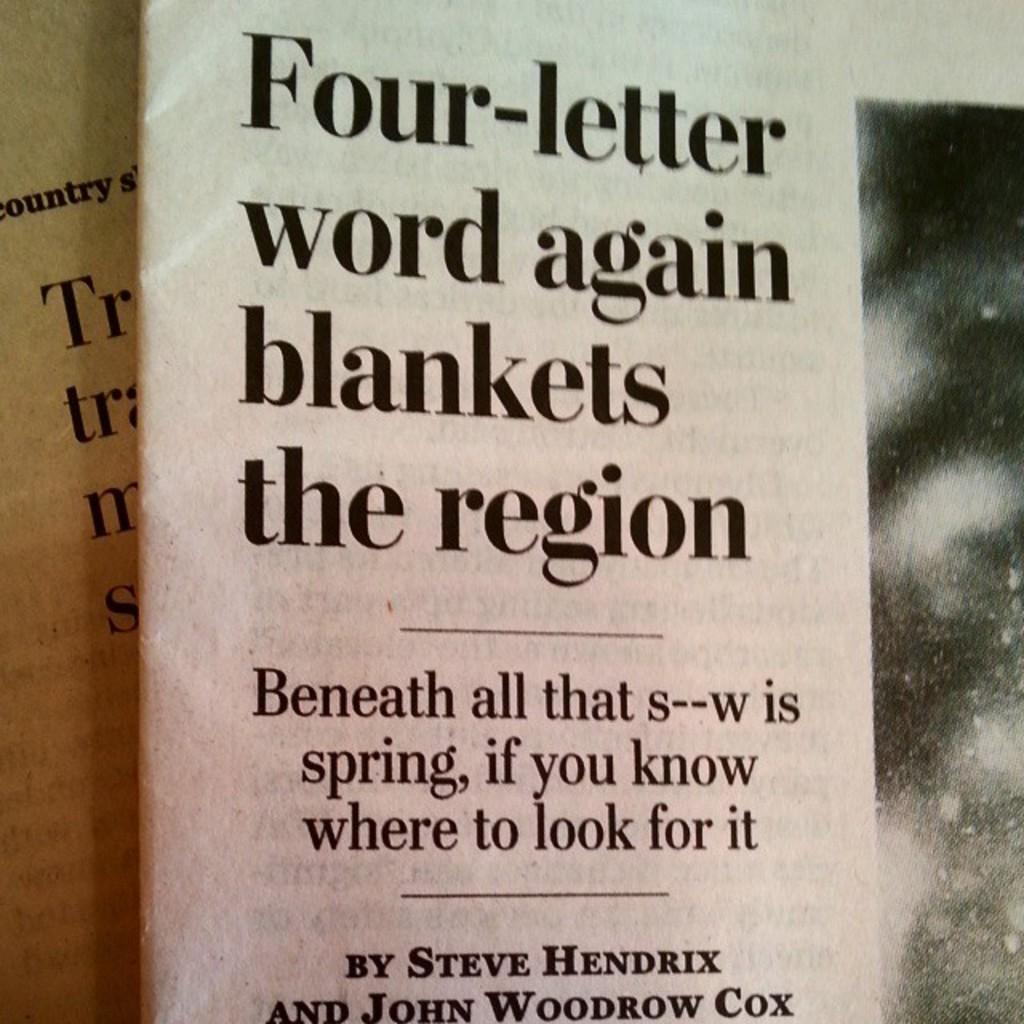<image>
Provide a brief description of the given image. An article headline with the title "Four-letter word again blankets the region." 